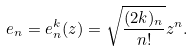<formula> <loc_0><loc_0><loc_500><loc_500>e _ { n } = e _ { n } ^ { k } ( z ) = \sqrt { \frac { ( 2 k ) _ { n } } { n ! } } z ^ { n } .</formula> 